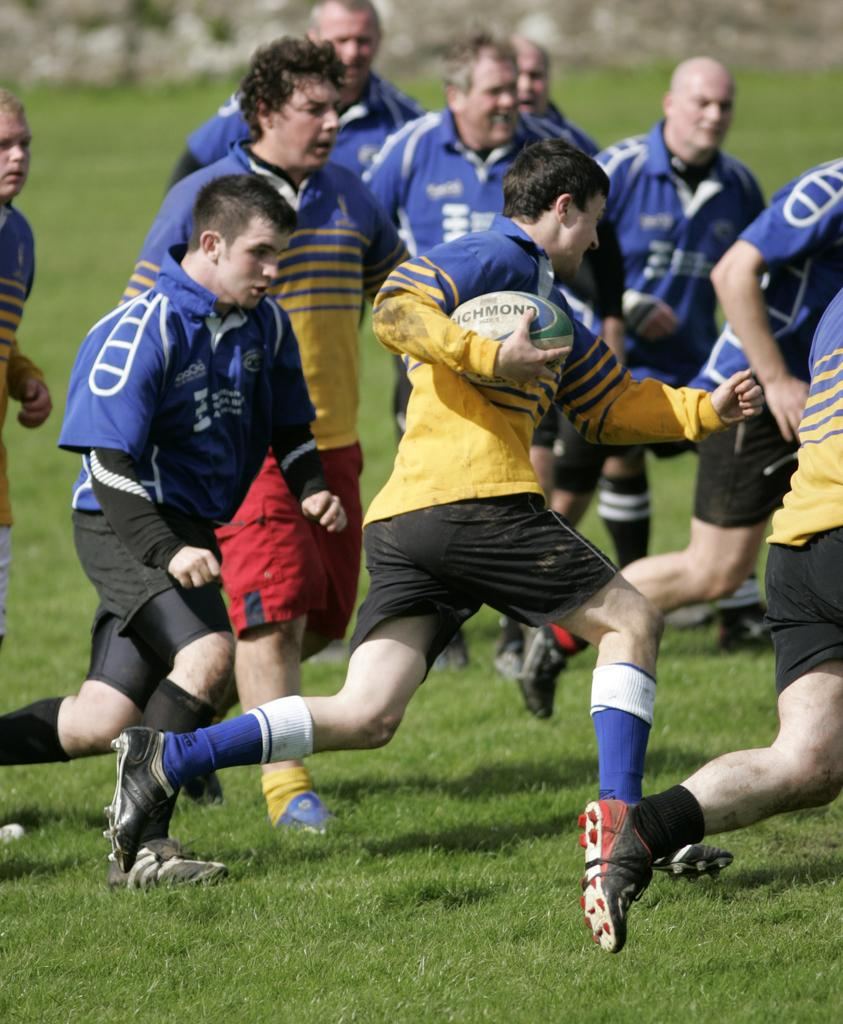What is happening in the image involving a group of people? There is a group of players in the image, and they are running on the ground. What object is being held by one of the players? One player is holding a ball. What type of wax is being used by the players to make their shoes slippery in the image? There is no wax present in the image, and the players' shoes do not appear to be slippery. 